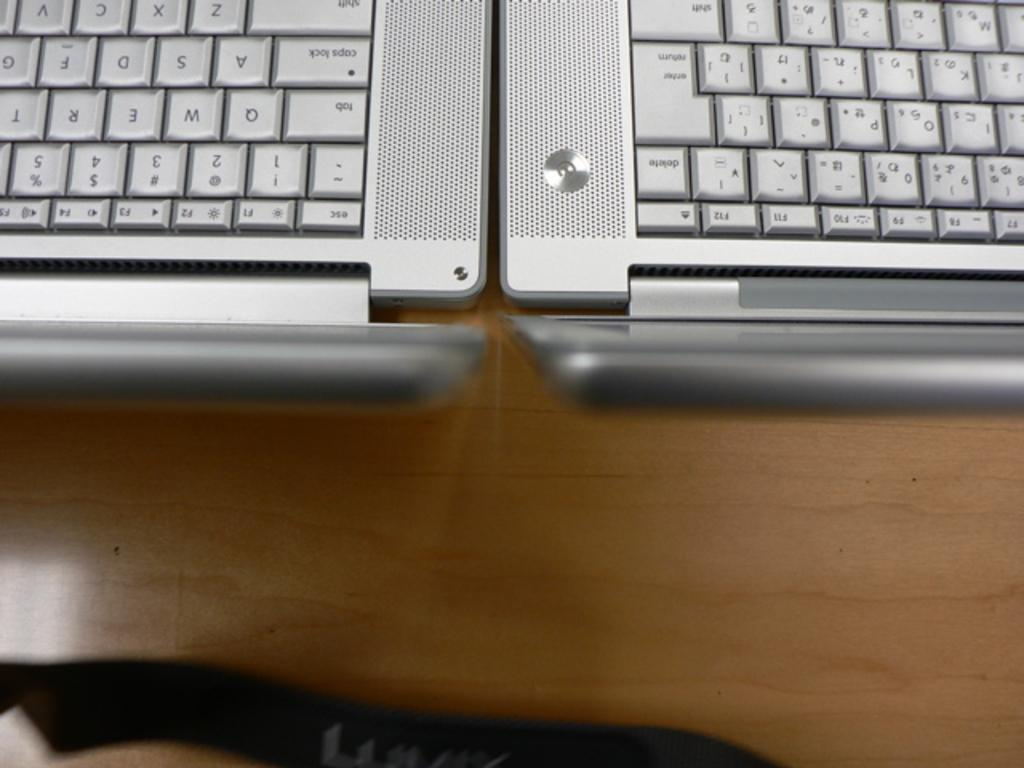What type of objects can be seen in the image? There are keyboards in the image. How many keyboards are visible in the image? The number of keyboards cannot be determined from the provided facts, but there are at least one or more keyboards present. What might the keyboards be used for? The keyboards might be used for typing or inputting data. Are there any dinosaurs playing with the keyboards in the image? There are no dinosaurs present in the image, and therefore no such activity can be observed. 